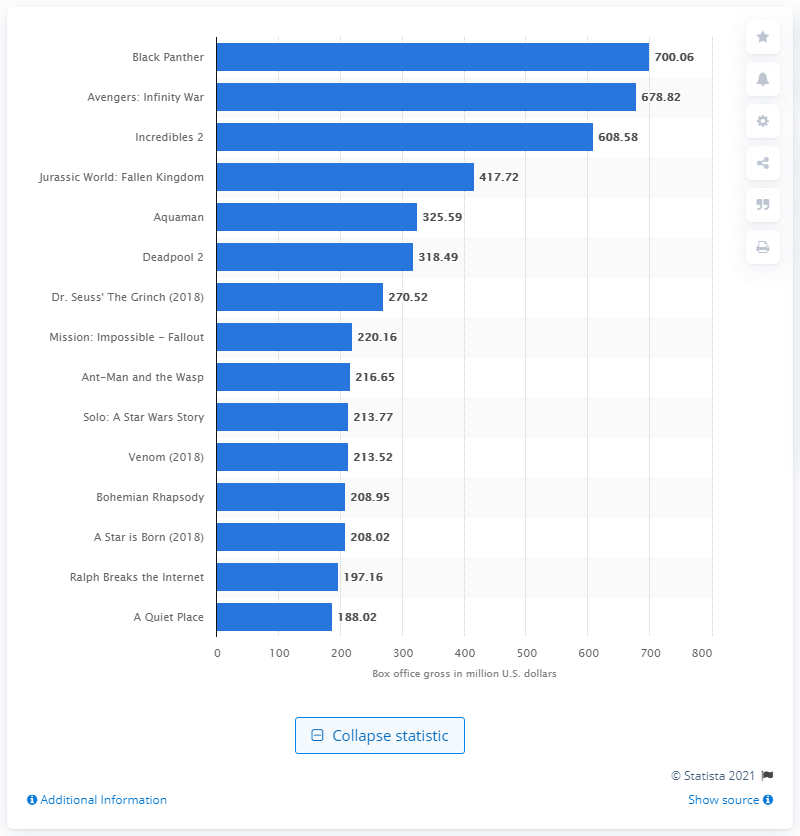Give some essential details in this illustration. In 2018, the movie "Black Panther" was the highest grossing movie of the year. The domestic box office revenue of Black Panther was approximately 700.06 million dollars. 